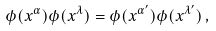<formula> <loc_0><loc_0><loc_500><loc_500>\phi ( x ^ { \alpha } ) \phi ( x ^ { \lambda } ) = \phi ( x ^ { \alpha ^ { \prime } } ) \phi ( x ^ { \lambda ^ { \prime } } ) \, ,</formula> 